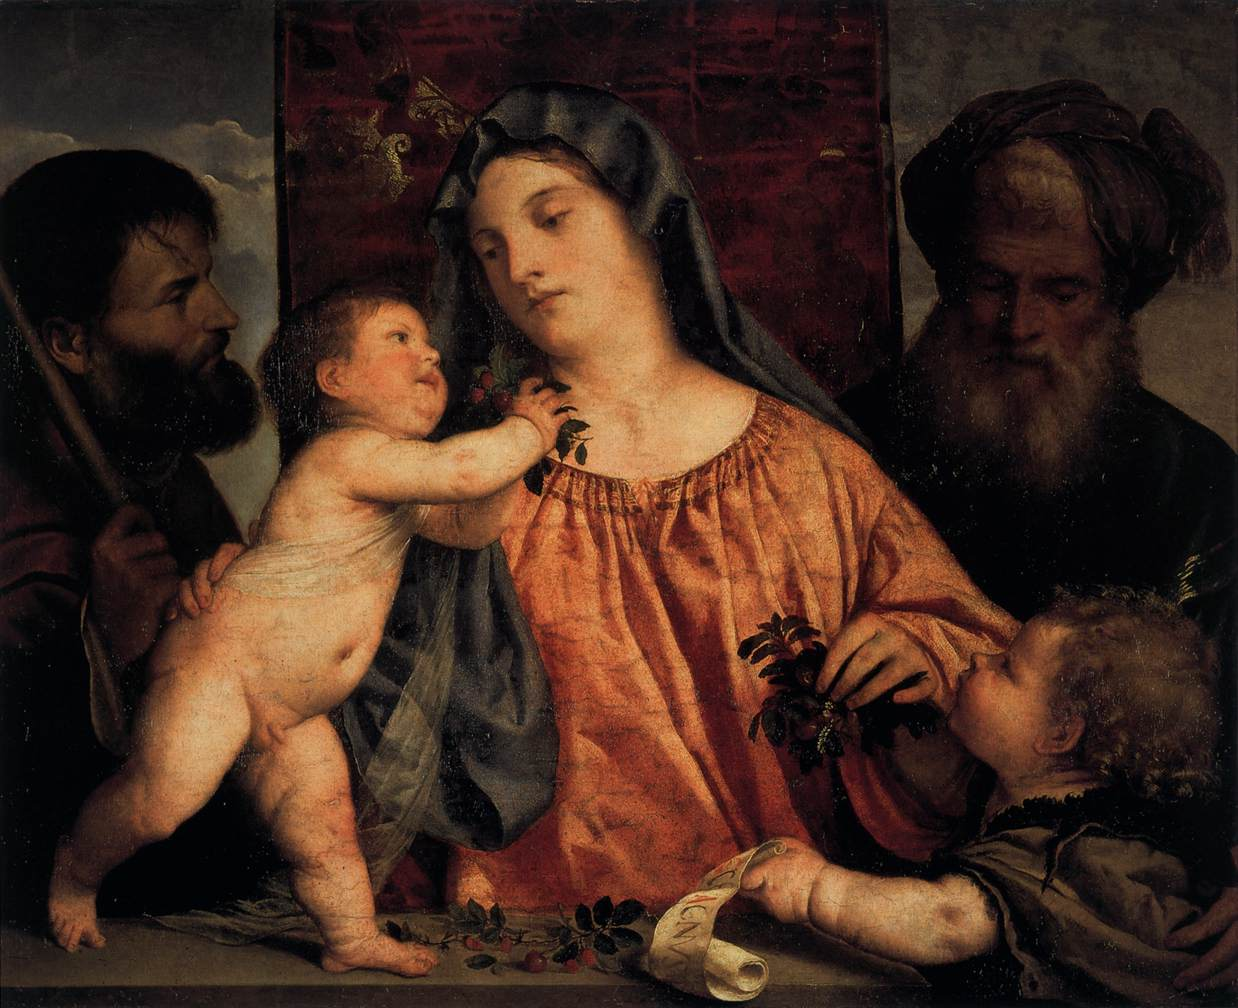Please describe the artistic techniques used in this painting. The artist utilizes a refined technique associated with the Renaissance period, likely employing oil on canvas or wood. There's a deliberate use of chiaroscuro, the contrast of light and shadow, to give form and volume to the figures. Soft gradations of color along with precise brushwork create a sense of texture in the garments and flesh, while subtle anatomical details suggest movement and life. The depth of the scene is achieved through atmospheric perspective in the landscape, and attention to composition is evident in the balanced placement of figures and the directional gaze that leads viewers through the narrative. 